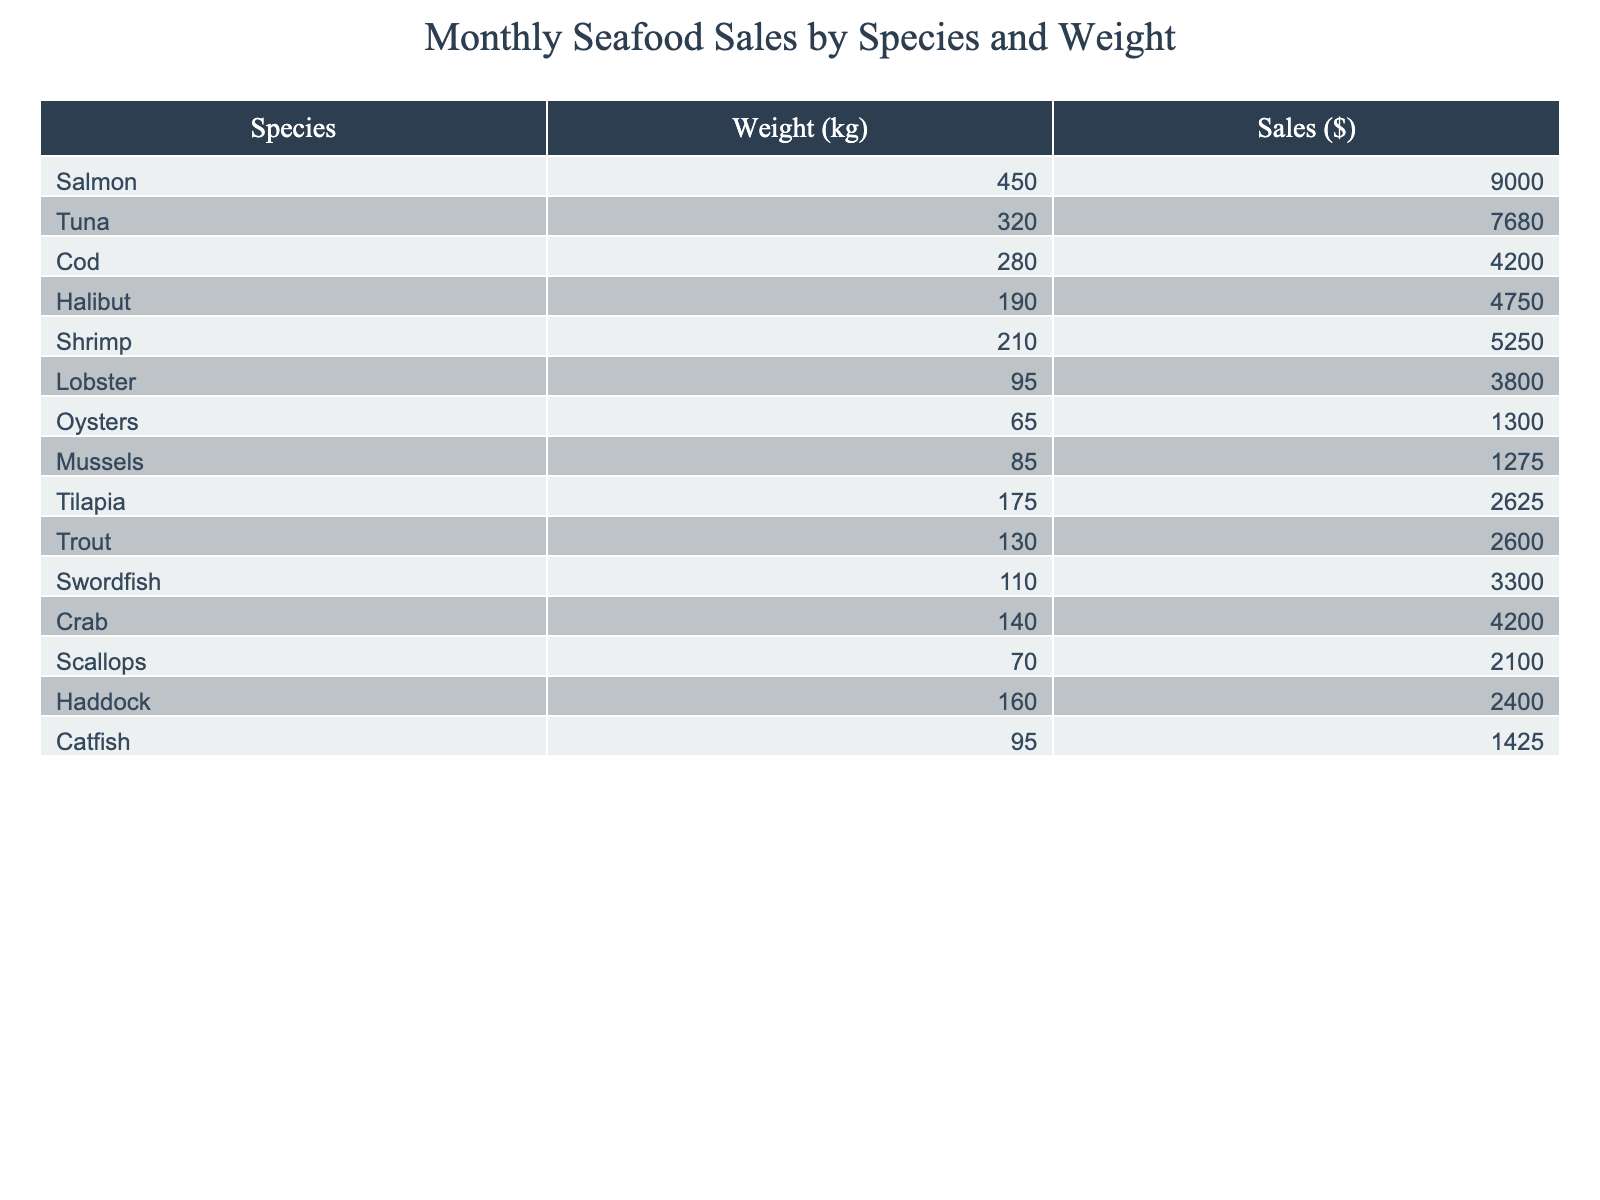What is the total sales for all seafood species combined? To calculate the total sales, sum the sales amounts listed for each species: 9000 + 7680 + 4200 + 4750 + 5250 + 3800 + 1300 + 1275 + 2625 + 2600 + 3300 + 4200 + 2100 + 2400 + 1425 =  52,810.
Answer: 52810 Which seafood species had the highest sales? The species with the highest sales is Salmon, which generated sales of $9,000.
Answer: Salmon What is the weight of the Tuna sold? The Tuna sold weighed 320 kg, as indicated in the table under the weight column for Tuna.
Answer: 320 What is the average weight of the seafood sold? To find the average weight, sum the weights of all species (450 + 320 + 280 + 190 + 210 + 95 + 65 + 85 + 175 + 130 + 110 + 140 + 70 + 160 + 95) = 2,960 kg. Then divide by the number of species, which is 15, giving an average weight of 2,960 / 15 ≈ 197.33 kg.
Answer: 197.33 Is the sales amount for Crab greater than its weight in kilograms? The sales for Crab are $4,200, and its weight is 140 kg. Since $4,200 is greater than 140, the statement is true.
Answer: Yes What is the total sales for shrimp and lobster combined? The sales for Shrimp are $5,250 and for Lobster $3,800. To find the combined sales, add the two amounts: 5250 + 3800 = 9,050.
Answer: 9050 How many species have sales greater than $5,000? Looking at the sales figures, the species with sales greater than $5,000 are Salmon, Tuna, and Shrimp. Hence, there are 3 species.
Answer: 3 What is the difference in sales between the highest and lowest selling seafood? The highest selling seafood is Salmon with $9,000 and the lowest is Oysters with $1,300. The difference is calculated as 9000 - 1300 = 7,700.
Answer: 7700 What percentage of total sales does the Halibut represent? Total sales is $52,810 as calculated previously and Halibut sales is $4,750. The percentage is (4750 / 52810) * 100 ≈ 8.99%.
Answer: 8.99% Is the average sales per species greater than $4,000? The total sales are $52,810, and there are 15 species. The average sales per species is 52,810 / 15 ≈ $3,520. Since $3,520 is less than $4,000, the answer is no.
Answer: No 